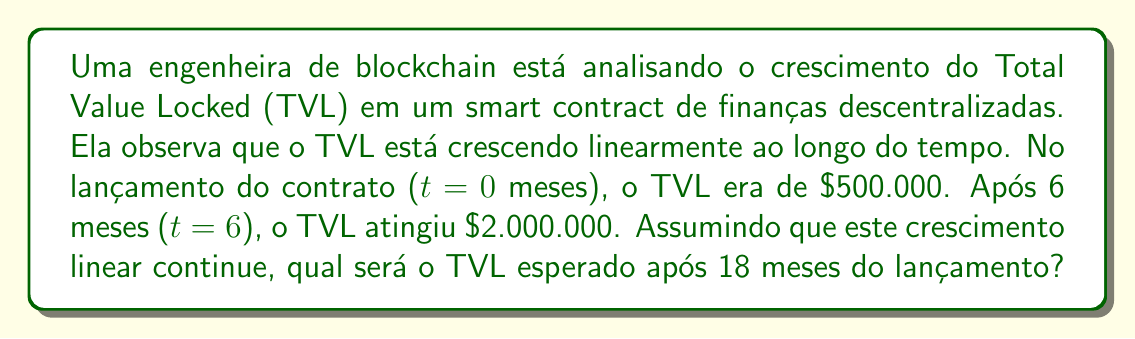Can you solve this math problem? Para resolver este problema, vamos usar a equação da reta na forma ponto-inclinação:

$$ y = m(x - x_1) + y_1 $$

Onde:
- $y$ é o TVL
- $x$ é o tempo em meses
- $m$ é a taxa de crescimento (inclinação da reta)
- $(x_1, y_1)$ é um ponto conhecido na reta

Primeiro, calculamos a inclinação $m$ usando os dois pontos dados:
$$ m = \frac{y_2 - y_1}{x_2 - x_1} = \frac{2.000.000 - 500.000}{6 - 0} = \frac{1.500.000}{6} = 250.000 $$

Agora, podemos usar o ponto inicial $(0, 500.000)$ e a inclinação para formar nossa equação:

$$ y = 250.000(x - 0) + 500.000 $$

Simplificando:

$$ y = 250.000x + 500.000 $$

Para encontrar o TVL após 18 meses, substituímos $x$ por 18:

$$ y = 250.000(18) + 500.000 = 4.500.000 + 500.000 = 5.000.000 $$

Portanto, o TVL esperado após 18 meses é $5.000.000.
Answer: $5.000.000 